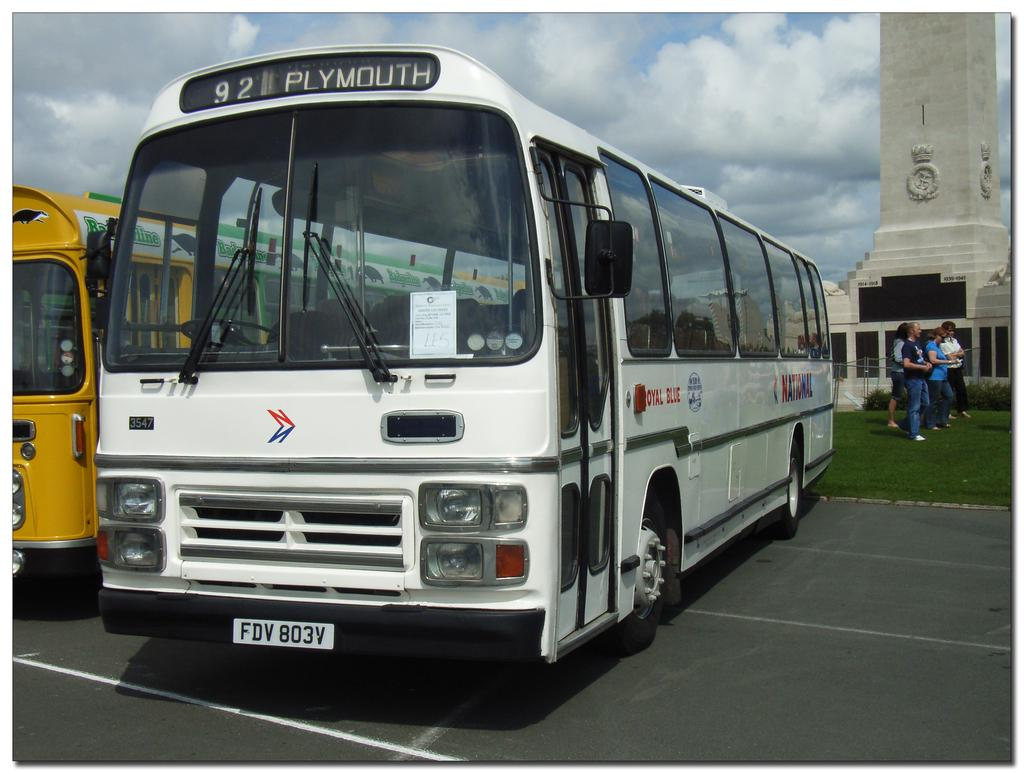What can be seen on the road in the image? There are vehicles on the road in the image. Where are the people located in the image? The people are on the green grass in the image. What is on the right side of the image? There is a tower on the right side of the image. What is visible in the sky in the image? Clouds are visible in the sky in the image. What type of bells can be heard ringing in the image? There are no bells present in the image, and therefore no sound can be heard. Can you describe the clam that is sitting on the grass in the image? There is no clam present in the image; the people are on the green grass. 